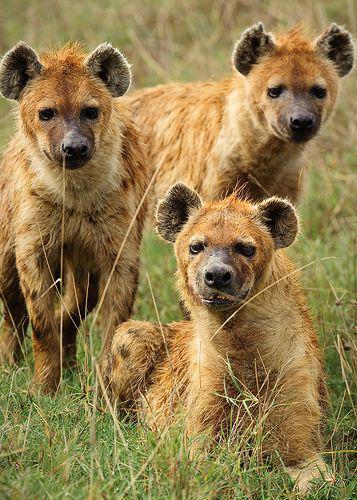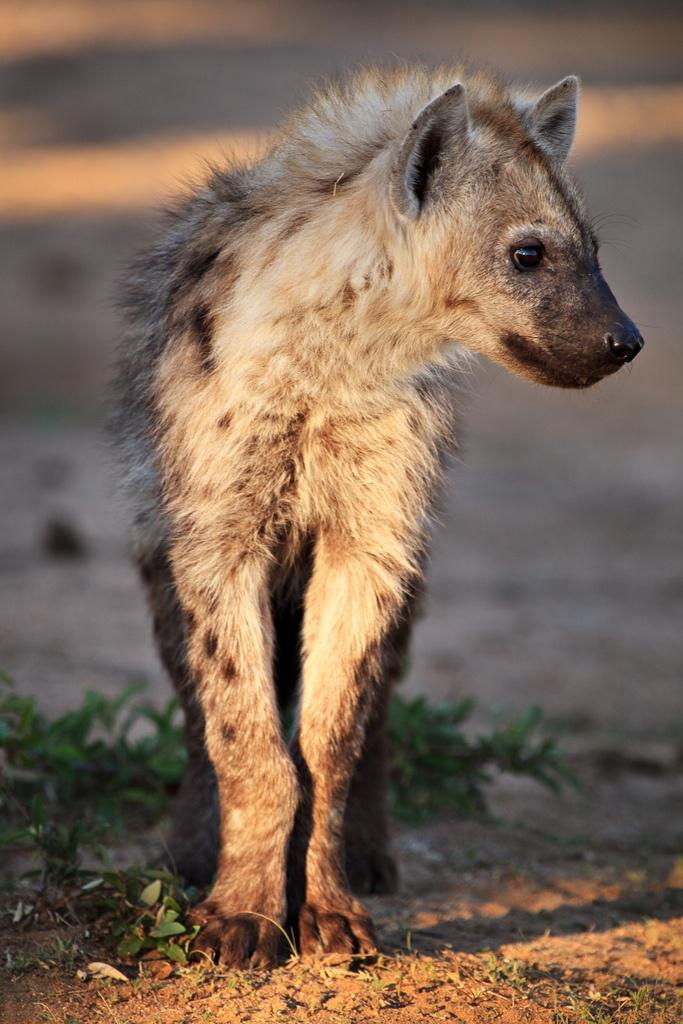The first image is the image on the left, the second image is the image on the right. Examine the images to the left and right. Is the description "The left image contains no more than one hyena." accurate? Answer yes or no. No. The first image is the image on the left, the second image is the image on the right. Assess this claim about the two images: "There is a species other than a hyena in at least one of the images.". Correct or not? Answer yes or no. No. 